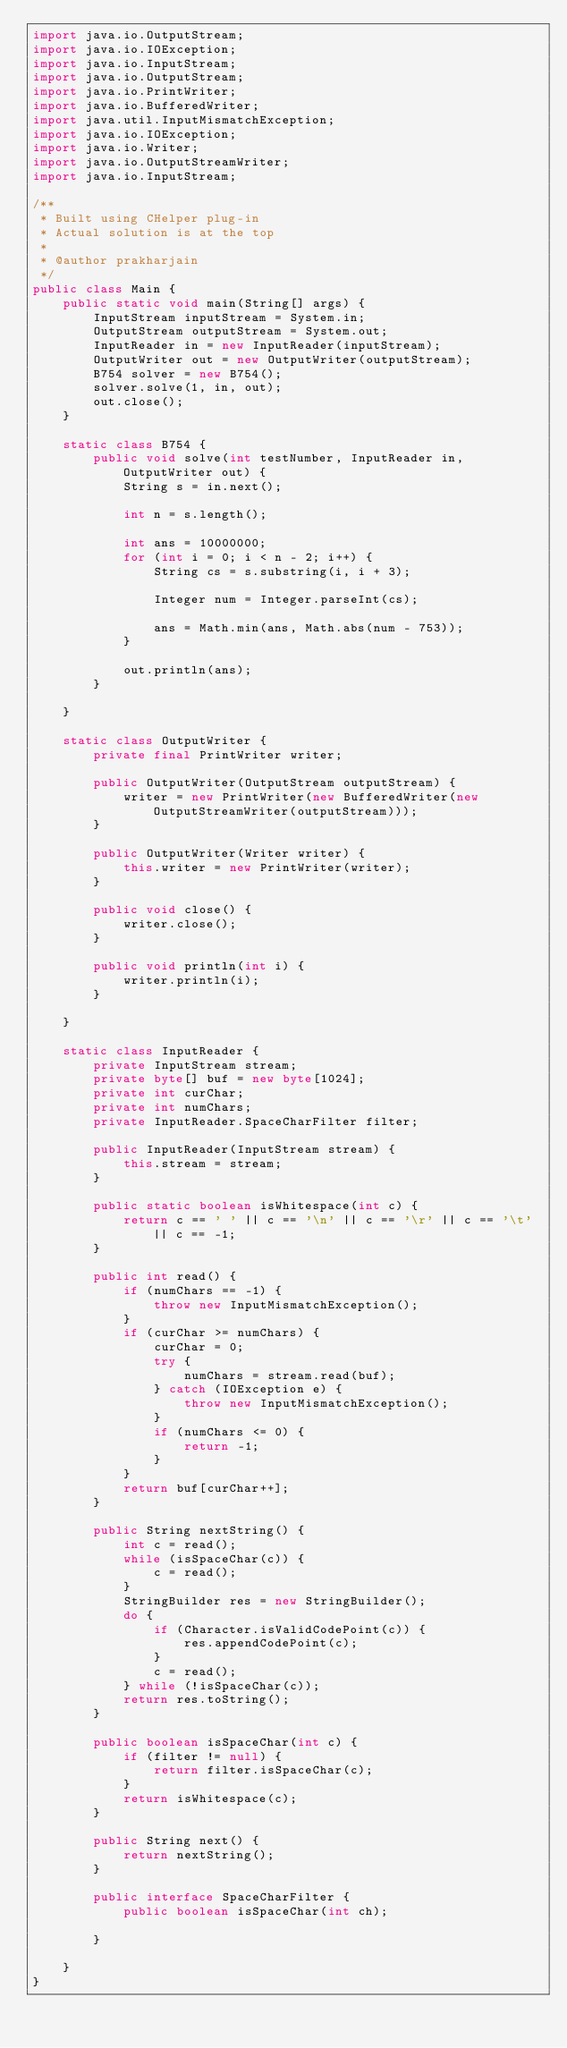Convert code to text. <code><loc_0><loc_0><loc_500><loc_500><_Java_>import java.io.OutputStream;
import java.io.IOException;
import java.io.InputStream;
import java.io.OutputStream;
import java.io.PrintWriter;
import java.io.BufferedWriter;
import java.util.InputMismatchException;
import java.io.IOException;
import java.io.Writer;
import java.io.OutputStreamWriter;
import java.io.InputStream;

/**
 * Built using CHelper plug-in
 * Actual solution is at the top
 *
 * @author prakharjain
 */
public class Main {
    public static void main(String[] args) {
        InputStream inputStream = System.in;
        OutputStream outputStream = System.out;
        InputReader in = new InputReader(inputStream);
        OutputWriter out = new OutputWriter(outputStream);
        B754 solver = new B754();
        solver.solve(1, in, out);
        out.close();
    }

    static class B754 {
        public void solve(int testNumber, InputReader in, OutputWriter out) {
            String s = in.next();

            int n = s.length();

            int ans = 10000000;
            for (int i = 0; i < n - 2; i++) {
                String cs = s.substring(i, i + 3);

                Integer num = Integer.parseInt(cs);

                ans = Math.min(ans, Math.abs(num - 753));
            }

            out.println(ans);
        }

    }

    static class OutputWriter {
        private final PrintWriter writer;

        public OutputWriter(OutputStream outputStream) {
            writer = new PrintWriter(new BufferedWriter(new OutputStreamWriter(outputStream)));
        }

        public OutputWriter(Writer writer) {
            this.writer = new PrintWriter(writer);
        }

        public void close() {
            writer.close();
        }

        public void println(int i) {
            writer.println(i);
        }

    }

    static class InputReader {
        private InputStream stream;
        private byte[] buf = new byte[1024];
        private int curChar;
        private int numChars;
        private InputReader.SpaceCharFilter filter;

        public InputReader(InputStream stream) {
            this.stream = stream;
        }

        public static boolean isWhitespace(int c) {
            return c == ' ' || c == '\n' || c == '\r' || c == '\t' || c == -1;
        }

        public int read() {
            if (numChars == -1) {
                throw new InputMismatchException();
            }
            if (curChar >= numChars) {
                curChar = 0;
                try {
                    numChars = stream.read(buf);
                } catch (IOException e) {
                    throw new InputMismatchException();
                }
                if (numChars <= 0) {
                    return -1;
                }
            }
            return buf[curChar++];
        }

        public String nextString() {
            int c = read();
            while (isSpaceChar(c)) {
                c = read();
            }
            StringBuilder res = new StringBuilder();
            do {
                if (Character.isValidCodePoint(c)) {
                    res.appendCodePoint(c);
                }
                c = read();
            } while (!isSpaceChar(c));
            return res.toString();
        }

        public boolean isSpaceChar(int c) {
            if (filter != null) {
                return filter.isSpaceChar(c);
            }
            return isWhitespace(c);
        }

        public String next() {
            return nextString();
        }

        public interface SpaceCharFilter {
            public boolean isSpaceChar(int ch);

        }

    }
}

</code> 